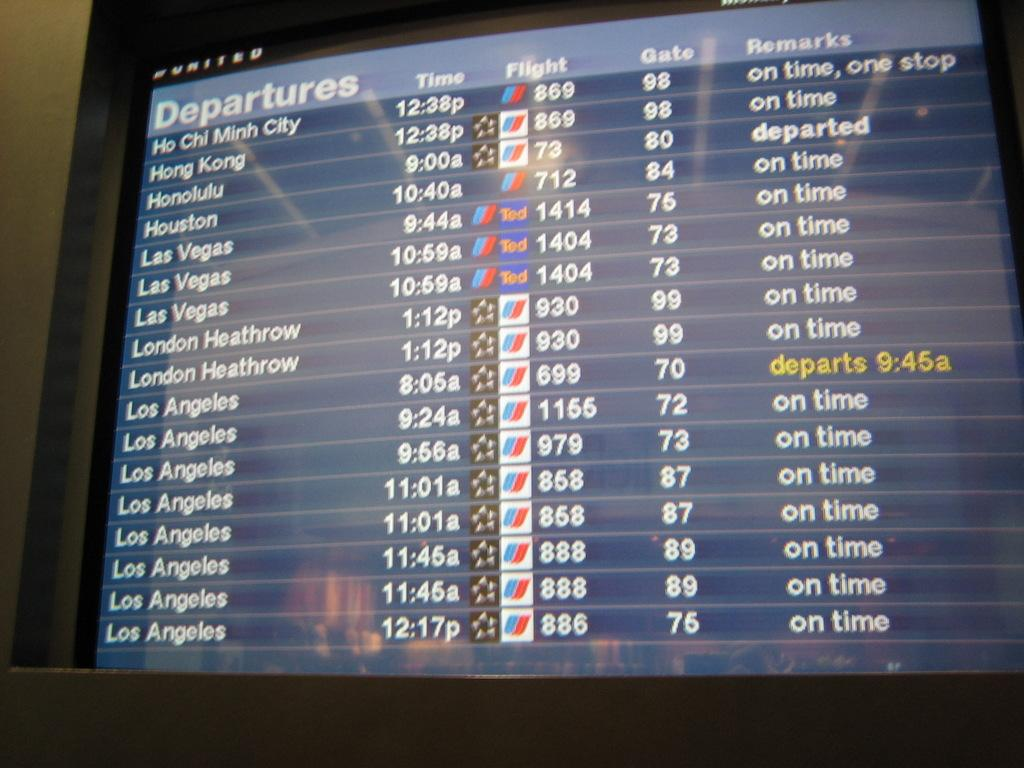<image>
Provide a brief description of the given image. The Departures board at an airport shows mostly on time flights. 